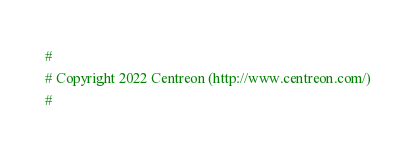<code> <loc_0><loc_0><loc_500><loc_500><_Perl_>#
# Copyright 2022 Centreon (http://www.centreon.com/)
#</code> 